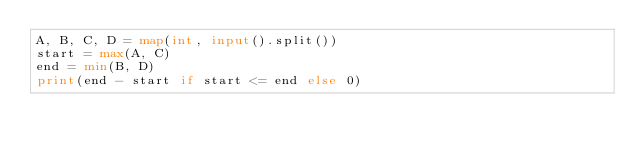Convert code to text. <code><loc_0><loc_0><loc_500><loc_500><_Python_>A, B, C, D = map(int, input().split())
start = max(A, C)
end = min(B, D)
print(end - start if start <= end else 0)
</code> 